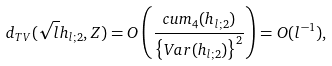<formula> <loc_0><loc_0><loc_500><loc_500>d _ { T V } ( \sqrt { l } h _ { l ; 2 } , Z ) = O \left ( \frac { c u m _ { 4 } ( h _ { l ; 2 } ) } { \left \{ V a r ( h _ { l ; 2 } ) \right \} ^ { 2 } } \right ) = O ( l ^ { - 1 } ) ,</formula> 